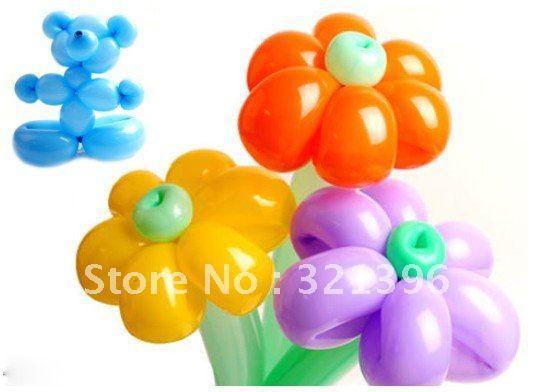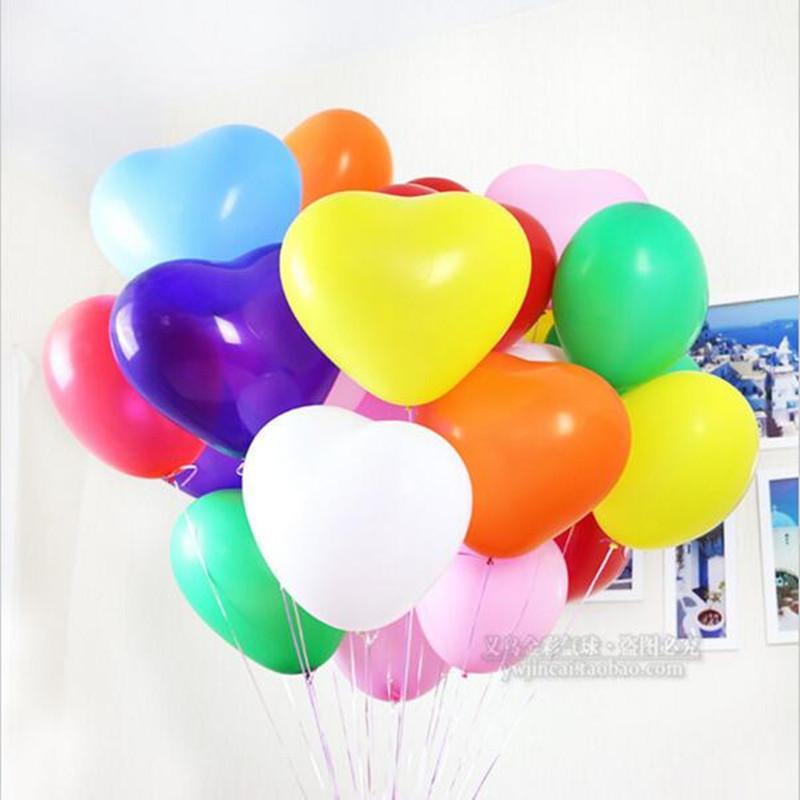The first image is the image on the left, the second image is the image on the right. Assess this claim about the two images: "In one of the images there is a stuffed bear next to multiple solid colored balloons.". Correct or not? Answer yes or no. No. 